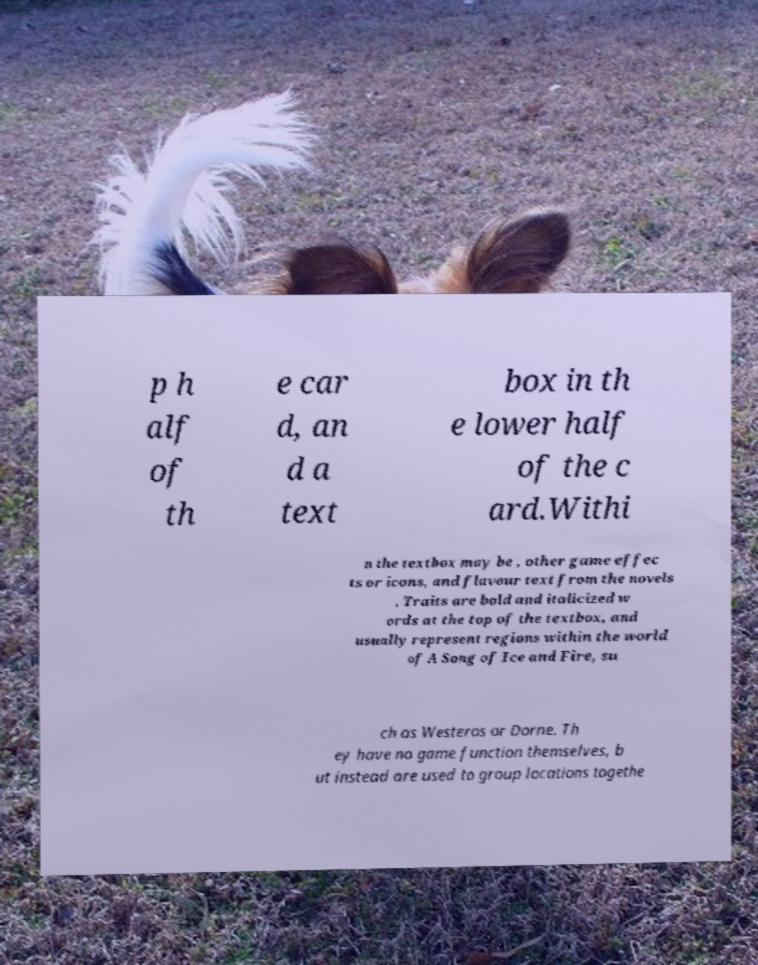Please read and relay the text visible in this image. What does it say? p h alf of th e car d, an d a text box in th e lower half of the c ard.Withi n the textbox may be , other game effec ts or icons, and flavour text from the novels . Traits are bold and italicized w ords at the top of the textbox, and usually represent regions within the world of A Song of Ice and Fire, su ch as Westeros or Dorne. Th ey have no game function themselves, b ut instead are used to group locations togethe 